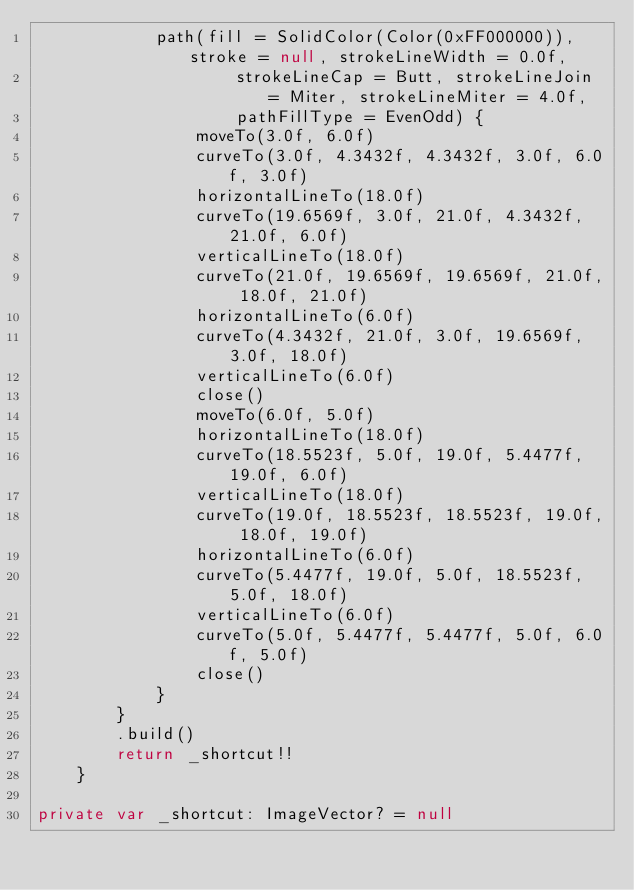Convert code to text. <code><loc_0><loc_0><loc_500><loc_500><_Kotlin_>            path(fill = SolidColor(Color(0xFF000000)), stroke = null, strokeLineWidth = 0.0f,
                    strokeLineCap = Butt, strokeLineJoin = Miter, strokeLineMiter = 4.0f,
                    pathFillType = EvenOdd) {
                moveTo(3.0f, 6.0f)
                curveTo(3.0f, 4.3432f, 4.3432f, 3.0f, 6.0f, 3.0f)
                horizontalLineTo(18.0f)
                curveTo(19.6569f, 3.0f, 21.0f, 4.3432f, 21.0f, 6.0f)
                verticalLineTo(18.0f)
                curveTo(21.0f, 19.6569f, 19.6569f, 21.0f, 18.0f, 21.0f)
                horizontalLineTo(6.0f)
                curveTo(4.3432f, 21.0f, 3.0f, 19.6569f, 3.0f, 18.0f)
                verticalLineTo(6.0f)
                close()
                moveTo(6.0f, 5.0f)
                horizontalLineTo(18.0f)
                curveTo(18.5523f, 5.0f, 19.0f, 5.4477f, 19.0f, 6.0f)
                verticalLineTo(18.0f)
                curveTo(19.0f, 18.5523f, 18.5523f, 19.0f, 18.0f, 19.0f)
                horizontalLineTo(6.0f)
                curveTo(5.4477f, 19.0f, 5.0f, 18.5523f, 5.0f, 18.0f)
                verticalLineTo(6.0f)
                curveTo(5.0f, 5.4477f, 5.4477f, 5.0f, 6.0f, 5.0f)
                close()
            }
        }
        .build()
        return _shortcut!!
    }

private var _shortcut: ImageVector? = null
</code> 